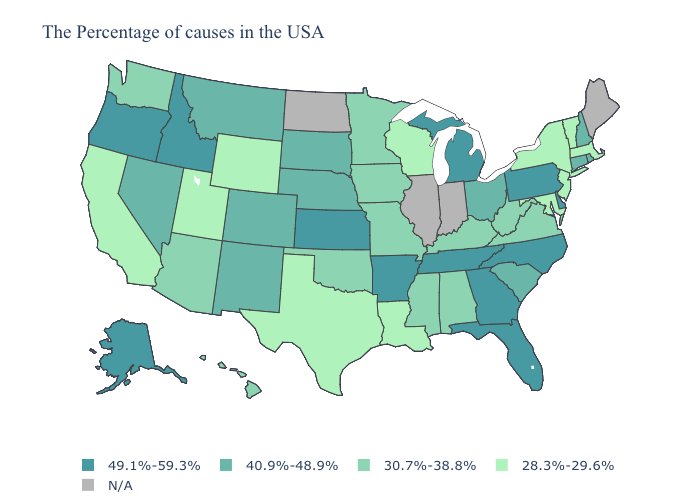Does the map have missing data?
Write a very short answer. Yes. What is the value of Oklahoma?
Quick response, please. 30.7%-38.8%. What is the highest value in the South ?
Give a very brief answer. 49.1%-59.3%. What is the lowest value in the USA?
Write a very short answer. 28.3%-29.6%. Among the states that border South Dakota , does Minnesota have the lowest value?
Quick response, please. No. How many symbols are there in the legend?
Short answer required. 5. Name the states that have a value in the range 49.1%-59.3%?
Be succinct. Delaware, Pennsylvania, North Carolina, Florida, Georgia, Michigan, Tennessee, Arkansas, Kansas, Idaho, Oregon, Alaska. Among the states that border Colorado , which have the lowest value?
Keep it brief. Wyoming, Utah. Which states have the lowest value in the MidWest?
Be succinct. Wisconsin. What is the value of Delaware?
Keep it brief. 49.1%-59.3%. What is the lowest value in the USA?
Short answer required. 28.3%-29.6%. Name the states that have a value in the range 49.1%-59.3%?
Concise answer only. Delaware, Pennsylvania, North Carolina, Florida, Georgia, Michigan, Tennessee, Arkansas, Kansas, Idaho, Oregon, Alaska. What is the highest value in the MidWest ?
Be succinct. 49.1%-59.3%. What is the value of Alaska?
Keep it brief. 49.1%-59.3%. Does North Carolina have the highest value in the USA?
Concise answer only. Yes. 